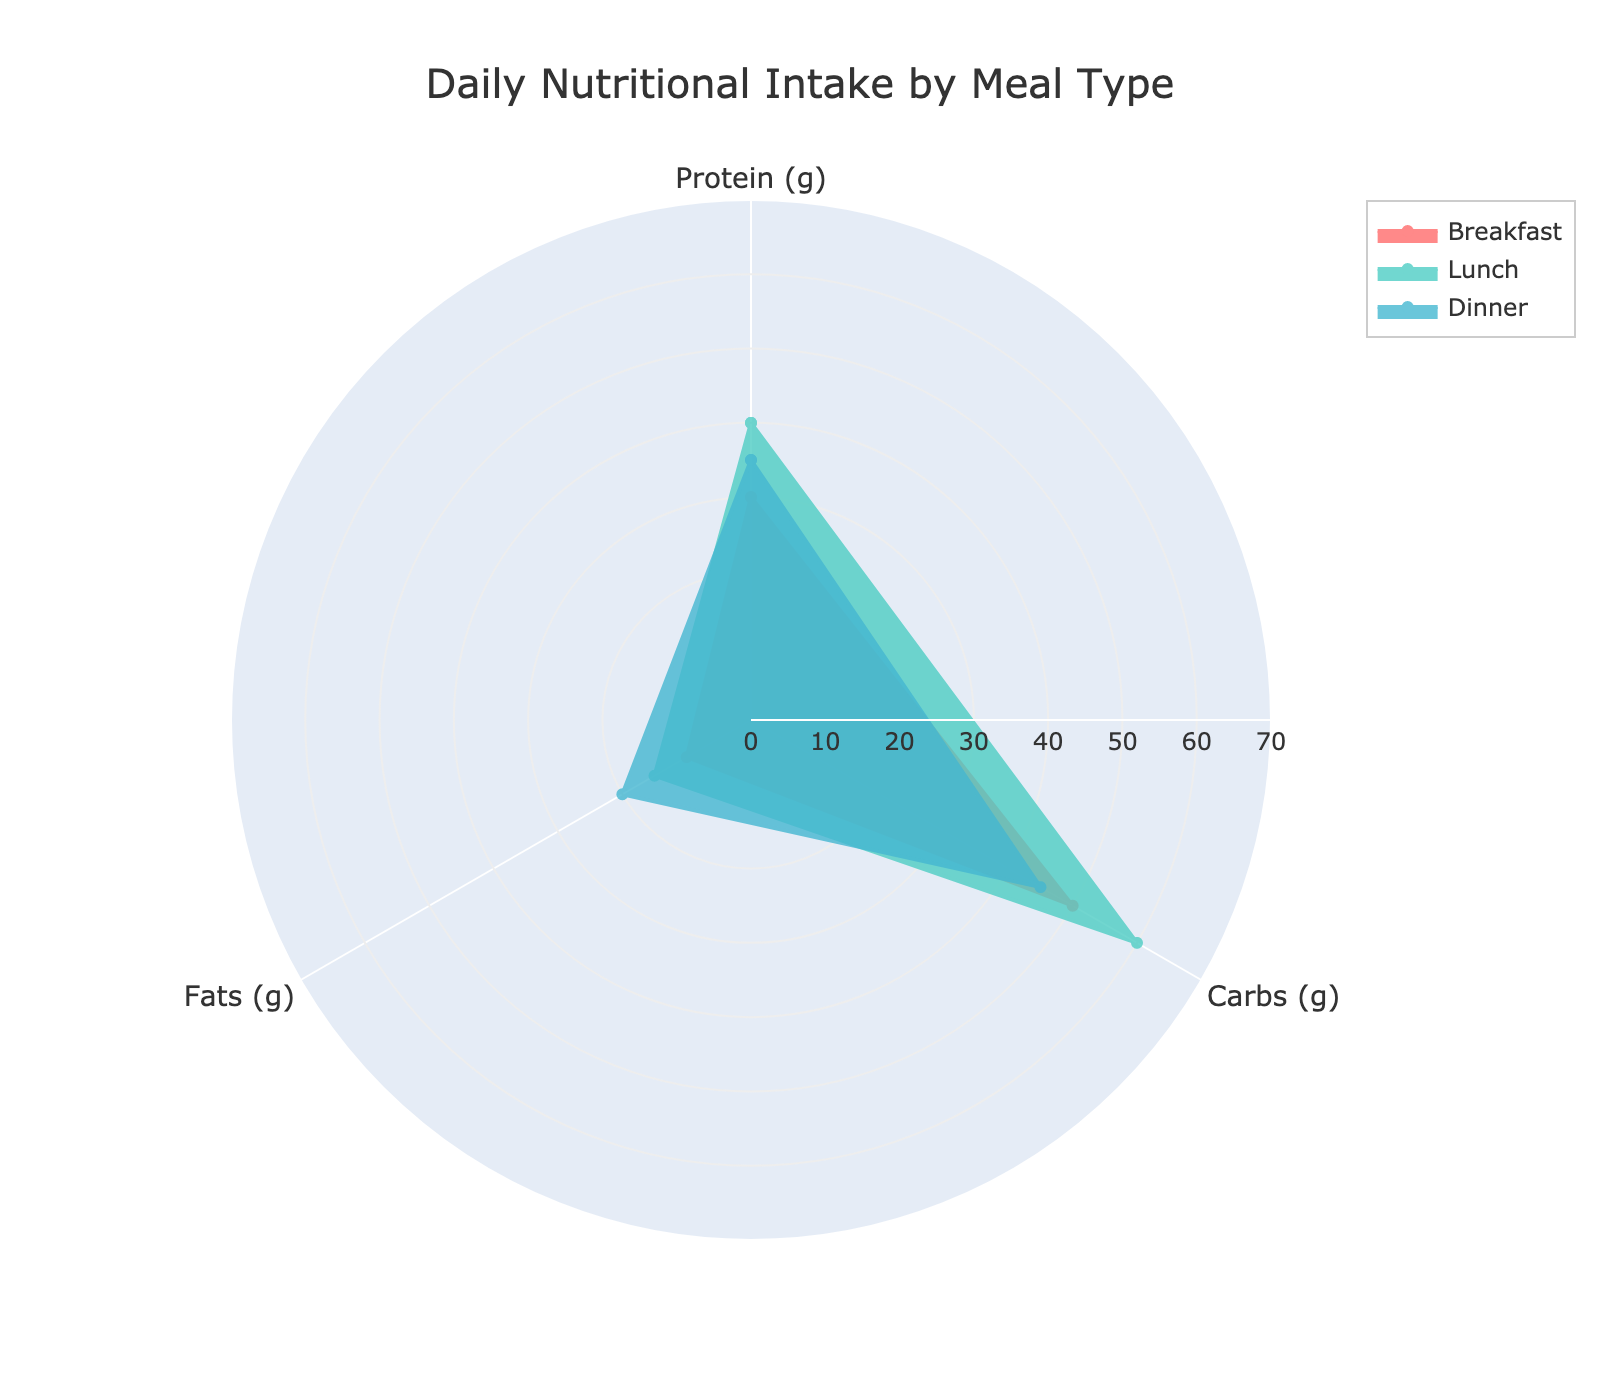How many meals are displayed in the figure? The figure visualizes three meal types, which are Breakfast, Lunch, and Dinner. Look at the legend to identify the different meal groups represented.
Answer: Three Which meal type has the highest carbohydrate intake? Observe each meal's carbohydrate values by looking at where their respective shapes extend along the "Carbs (g)" axis. The shape extending the furthest indicates the highest intake. Lunch has the highest carbohydrate intake.
Answer: Lunch Which nutrient has the highest intake in Dinner? Check the Dinner polygon and note the axis on which the polygon extends the furthest. Dinner's polygon extends the furthest on the "Protein (g)" axis, indicating the highest intake.
Answer: Protein Calculate the total protein intake for all meals. Sum the protein values of Breakfast (30g), Lunch (40g), and Dinner (35g). The calculation: 30 + 40 + 35 = 105 grams.
Answer: 105 grams Compare the fat intake between Breakfast and Dinner. Which meal has more fats? Examine the "Fats (g)" axis for both Breakfast and Dinner. The Dinner shape extends further than the Breakfast shape. So, Dinner has more fats.
Answer: Dinner Is there any meal type where the carbohydrate intake is less than 50 grams? Check the carbohydrate axes for all meal types. Only Dinner has its carbohydrate value at 45g, which is less than 50g.
Answer: Dinner Which meal type has the smallest difference between protein and fat intake? Calculate the absolute differences for each meal: Breakfast (30g - 10g = 20g), Lunch (40g - 15g = 25g), and Dinner (35g - 20g = 15g). The smallest difference is in Dinner.
Answer: Dinner What is the average fat intake across all meals? Sum the fat intake for all meals: Breakfast (10g), Lunch (15g), and Dinner (20g). Then divide by the number of meals: (10 + 15 + 20) / 3 = 45 / 3 = 15 grams.
Answer: 15 grams Which two meal types have the closest protein intake values? Compare the protein intake values: Breakfast (30g), Lunch (40g), and Dinner (35g). The closest values are Dinner (35g) and Breakfast (30g) with a difference of 5 grams.
Answer: Breakfast and Dinner Identify the meal with the most balanced distribution of nutrients. Look for the meal with the least variation among its protein, carbohydrates, and fats values. Dinner (Protein: 35g, Carbs: 45g, Fats: 20g) seems most balanced, as the values are closer compared to Breakfast and Lunch.
Answer: Dinner 